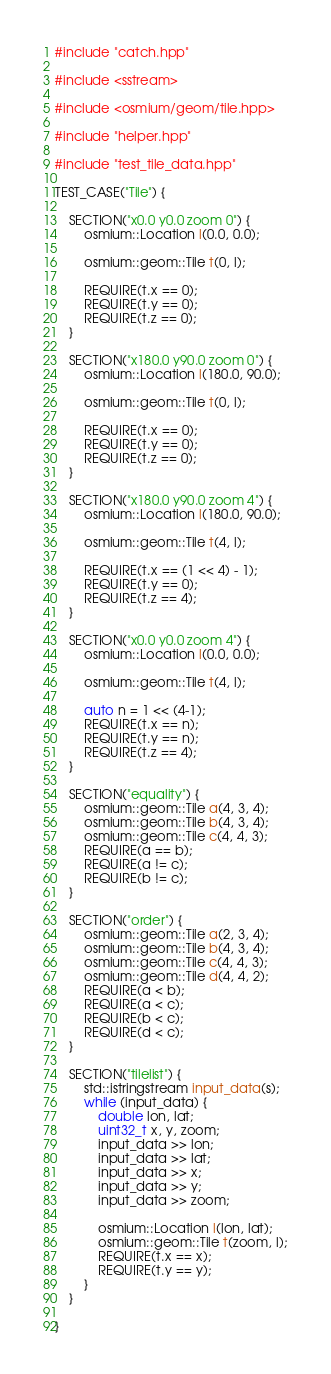<code> <loc_0><loc_0><loc_500><loc_500><_C++_>#include "catch.hpp"

#include <sstream>

#include <osmium/geom/tile.hpp>

#include "helper.hpp"

#include "test_tile_data.hpp"

TEST_CASE("Tile") {

    SECTION("x0.0 y0.0 zoom 0") {
        osmium::Location l(0.0, 0.0);

        osmium::geom::Tile t(0, l);

        REQUIRE(t.x == 0);
        REQUIRE(t.y == 0);
        REQUIRE(t.z == 0);
    }

    SECTION("x180.0 y90.0 zoom 0") {
        osmium::Location l(180.0, 90.0);

        osmium::geom::Tile t(0, l);

        REQUIRE(t.x == 0);
        REQUIRE(t.y == 0);
        REQUIRE(t.z == 0);
    }

    SECTION("x180.0 y90.0 zoom 4") {
        osmium::Location l(180.0, 90.0);

        osmium::geom::Tile t(4, l);

        REQUIRE(t.x == (1 << 4) - 1);
        REQUIRE(t.y == 0);
        REQUIRE(t.z == 4);
    }

    SECTION("x0.0 y0.0 zoom 4") {
        osmium::Location l(0.0, 0.0);

        osmium::geom::Tile t(4, l);

        auto n = 1 << (4-1);
        REQUIRE(t.x == n);
        REQUIRE(t.y == n);
        REQUIRE(t.z == 4);
    }

    SECTION("equality") {
        osmium::geom::Tile a(4, 3, 4);
        osmium::geom::Tile b(4, 3, 4);
        osmium::geom::Tile c(4, 4, 3);
        REQUIRE(a == b);
        REQUIRE(a != c);
        REQUIRE(b != c);
    }

    SECTION("order") {
        osmium::geom::Tile a(2, 3, 4);
        osmium::geom::Tile b(4, 3, 4);
        osmium::geom::Tile c(4, 4, 3);
        osmium::geom::Tile d(4, 4, 2);
        REQUIRE(a < b);
        REQUIRE(a < c);
        REQUIRE(b < c);
        REQUIRE(d < c);
    }

    SECTION("tilelist") {
        std::istringstream input_data(s);
        while (input_data) {
            double lon, lat;
            uint32_t x, y, zoom;
            input_data >> lon;
            input_data >> lat;
            input_data >> x;
            input_data >> y;
            input_data >> zoom;

            osmium::Location l(lon, lat);
            osmium::geom::Tile t(zoom, l);
            REQUIRE(t.x == x);
            REQUIRE(t.y == y);
        }
    }

}

</code> 